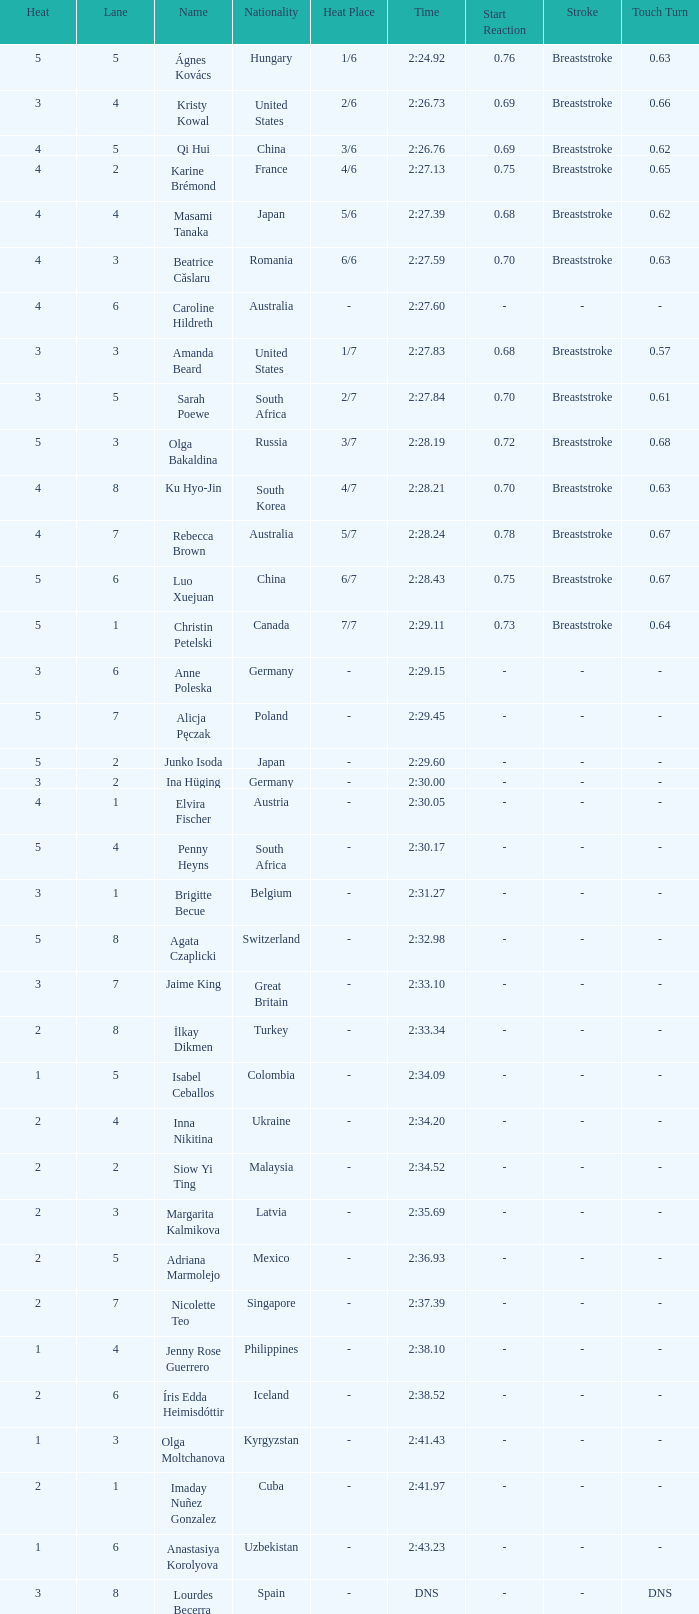What lane did inna nikitina have? 4.0. 